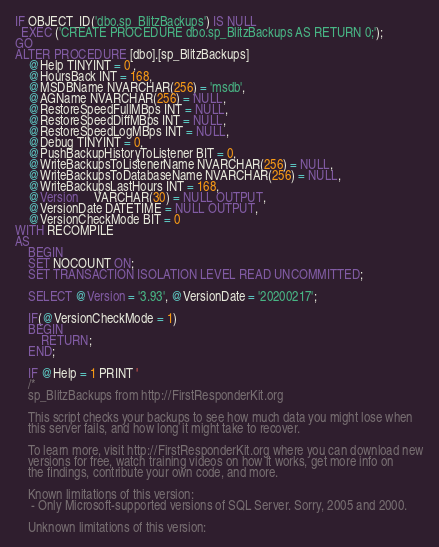Convert code to text. <code><loc_0><loc_0><loc_500><loc_500><_SQL_>IF OBJECT_ID('dbo.sp_BlitzBackups') IS NULL
  EXEC ('CREATE PROCEDURE dbo.sp_BlitzBackups AS RETURN 0;');
GO
ALTER PROCEDURE [dbo].[sp_BlitzBackups]
    @Help TINYINT = 0 ,
	@HoursBack INT = 168,
	@MSDBName NVARCHAR(256) = 'msdb',
	@AGName NVARCHAR(256) = NULL,
	@RestoreSpeedFullMBps INT = NULL,
	@RestoreSpeedDiffMBps INT = NULL,
	@RestoreSpeedLogMBps INT = NULL,
	@Debug TINYINT = 0,
	@PushBackupHistoryToListener BIT = 0,
	@WriteBackupsToListenerName NVARCHAR(256) = NULL,
    @WriteBackupsToDatabaseName NVARCHAR(256) = NULL,
    @WriteBackupsLastHours INT = 168,
    @Version     VARCHAR(30) = NULL OUTPUT,
	@VersionDate DATETIME = NULL OUTPUT,
    @VersionCheckMode BIT = 0
WITH RECOMPILE
AS
	BEGIN
    SET NOCOUNT ON;
	SET TRANSACTION ISOLATION LEVEL READ UNCOMMITTED;
	
	SELECT @Version = '3.93', @VersionDate = '20200217';
	
	IF(@VersionCheckMode = 1)
	BEGIN
		RETURN;
	END;

	IF @Help = 1 PRINT '
	/*
	sp_BlitzBackups from http://FirstResponderKit.org
	
	This script checks your backups to see how much data you might lose when
	this server fails, and how long it might take to recover.

	To learn more, visit http://FirstResponderKit.org where you can download new
	versions for free, watch training videos on how it works, get more info on
	the findings, contribute your own code, and more.

	Known limitations of this version:
	 - Only Microsoft-supported versions of SQL Server. Sorry, 2005 and 2000.

	Unknown limitations of this version:</code> 